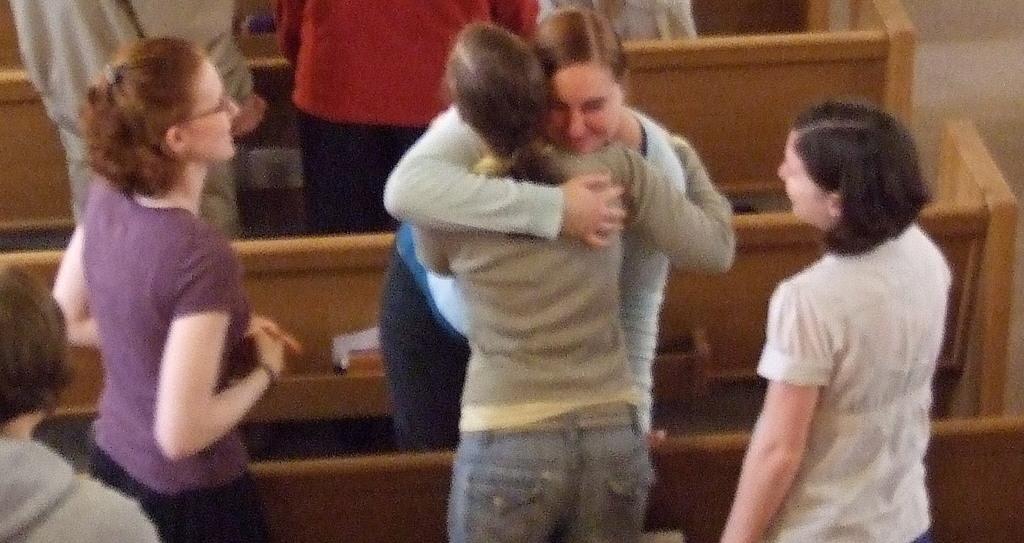Could you give a brief overview of what you see in this image? In this picture we can see a group of people standing on the floor where two women are hugging, wooden objects. 